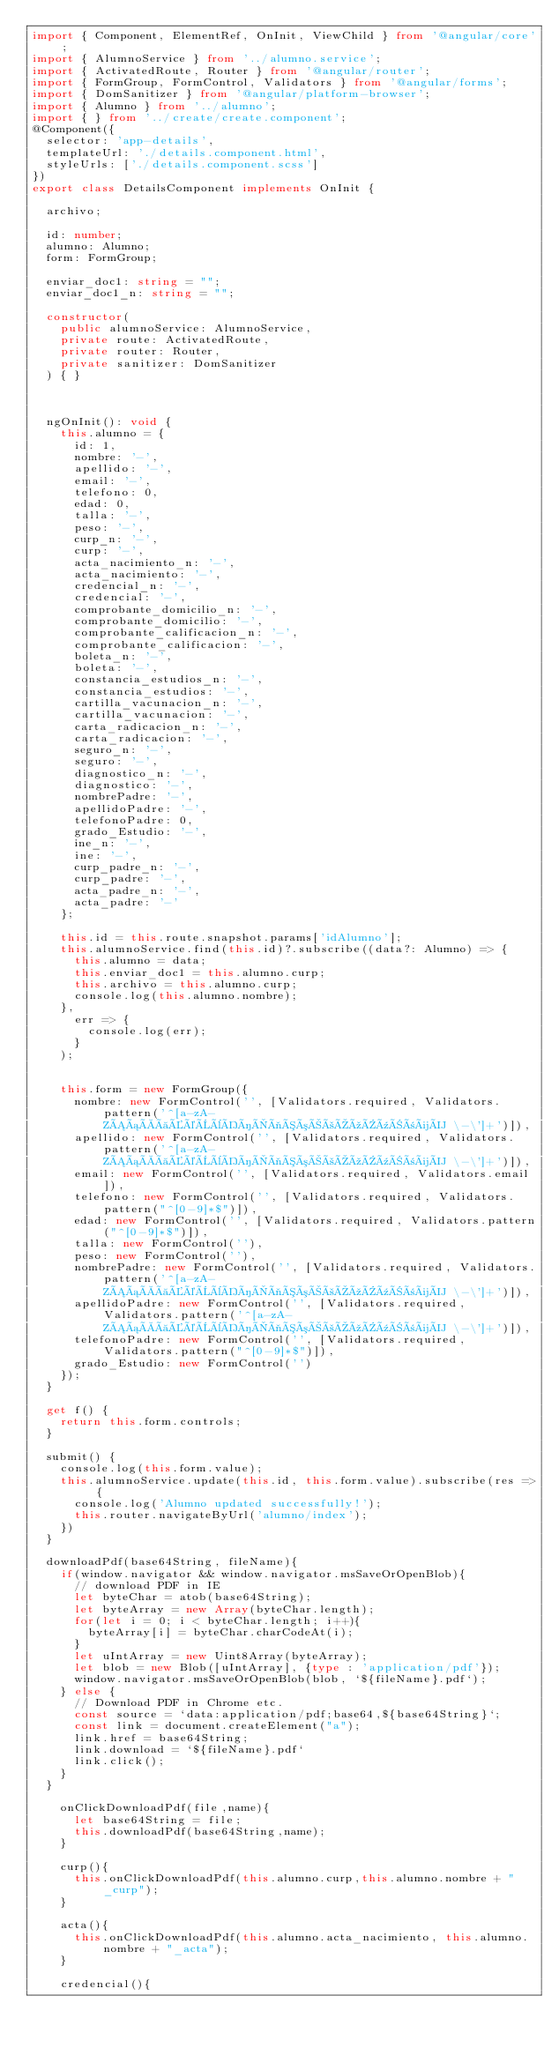<code> <loc_0><loc_0><loc_500><loc_500><_TypeScript_>import { Component, ElementRef, OnInit, ViewChild } from '@angular/core';
import { AlumnoService } from '../alumno.service';
import { ActivatedRoute, Router } from '@angular/router';
import { FormGroup, FormControl, Validators } from '@angular/forms';
import { DomSanitizer } from '@angular/platform-browser';
import { Alumno } from '../alumno';
import { } from '../create/create.component';
@Component({
  selector: 'app-details',
  templateUrl: './details.component.html',
  styleUrls: ['./details.component.scss']
})
export class DetailsComponent implements OnInit {

  archivo;

  id: number;
  alumno: Alumno;
  form: FormGroup;

  enviar_doc1: string = "";
  enviar_doc1_n: string = "";

  constructor(
    public alumnoService: AlumnoService,
    private route: ActivatedRoute,
    private router: Router,
    private sanitizer: DomSanitizer
  ) { }

  

  ngOnInit(): void {
    this.alumno = {
      id: 1,
      nombre: '-',
      apellido: '-',
      email: '-',
      telefono: 0,
      edad: 0,
      talla: '-',
      peso: '-',
      curp_n: '-',
      curp: '-',
      acta_nacimiento_n: '-',
      acta_nacimiento: '-',
      credencial_n: '-',
      credencial: '-',
      comprobante_domicilio_n: '-',
      comprobante_domicilio: '-',
      comprobante_calificacion_n: '-',
      comprobante_calificacion: '-',
      boleta_n: '-',
      boleta: '-',
      constancia_estudios_n: '-',
      constancia_estudios: '-',
      cartilla_vacunacion_n: '-',
      cartilla_vacunacion: '-',
      carta_radicacion_n: '-',
      carta_radicacion: '-',
      seguro_n: '-',
      seguro: '-',
      diagnostico_n: '-',
      diagnostico: '-',
      nombrePadre: '-',
      apellidoPadre: '-',
      telefonoPadre: 0,
      grado_Estudio: '-',
      ine_n: '-',
      ine: '-',
      curp_padre_n: '-',
      curp_padre: '-',
      acta_padre_n: '-',
      acta_padre: '-'
    };

    this.id = this.route.snapshot.params['idAlumno'];
    this.alumnoService.find(this.id)?.subscribe((data?: Alumno) => {
      this.alumno = data;
      this.enviar_doc1 = this.alumno.curp;
      this.archivo = this.alumno.curp;
      console.log(this.alumno.nombre);
    },
      err => {
        console.log(err);
      }
    );


    this.form = new FormGroup({
      nombre: new FormControl('', [Validators.required, Validators.pattern('^[a-zA-ZÁáÀàÉéÈèÍíÌìÓóÒòÚúÙùÑñüÜ \-\']+')]),
      apellido: new FormControl('', [Validators.required, Validators.pattern('^[a-zA-ZÁáÀàÉéÈèÍíÌìÓóÒòÚúÙùÑñüÜ \-\']+')]),
      email: new FormControl('', [Validators.required, Validators.email]),
      telefono: new FormControl('', [Validators.required, Validators.pattern("^[0-9]*$")]),
      edad: new FormControl('', [Validators.required, Validators.pattern("^[0-9]*$")]),
      talla: new FormControl(''),
      peso: new FormControl(''),
      nombrePadre: new FormControl('', [Validators.required, Validators.pattern('^[a-zA-ZÁáÀàÉéÈèÍíÌìÓóÒòÚúÙùÑñüÜ \-\']+')]),
      apellidoPadre: new FormControl('', [Validators.required, Validators.pattern('^[a-zA-ZÁáÀàÉéÈèÍíÌìÓóÒòÚúÙùÑñüÜ \-\']+')]),
      telefonoPadre: new FormControl('', [Validators.required, Validators.pattern("^[0-9]*$")]),
      grado_Estudio: new FormControl('')
    });
  }

  get f() {
    return this.form.controls;
  }

  submit() {
    console.log(this.form.value);
    this.alumnoService.update(this.id, this.form.value).subscribe(res => {
      console.log('Alumno updated successfully!');
      this.router.navigateByUrl('alumno/index');
    })
  }

  downloadPdf(base64String, fileName){
    if(window.navigator && window.navigator.msSaveOrOpenBlob){ 
      // download PDF in IE
      let byteChar = atob(base64String);
      let byteArray = new Array(byteChar.length);
      for(let i = 0; i < byteChar.length; i++){
        byteArray[i] = byteChar.charCodeAt(i);
      }
      let uIntArray = new Uint8Array(byteArray);
      let blob = new Blob([uIntArray], {type : 'application/pdf'});
      window.navigator.msSaveOrOpenBlob(blob, `${fileName}.pdf`);
    } else {
      // Download PDF in Chrome etc.
      const source = `data:application/pdf;base64,${base64String}`;
      const link = document.createElement("a");
      link.href = base64String;
      link.download = `${fileName}.pdf`
      link.click();
    }
  }

    onClickDownloadPdf(file,name){
      let base64String = file;
      this.downloadPdf(base64String,name);
    }

    curp(){
      this.onClickDownloadPdf(this.alumno.curp,this.alumno.nombre + "_curp");
    }

    acta(){
      this.onClickDownloadPdf(this.alumno.acta_nacimiento, this.alumno.nombre + "_acta");
    }

    credencial(){</code> 